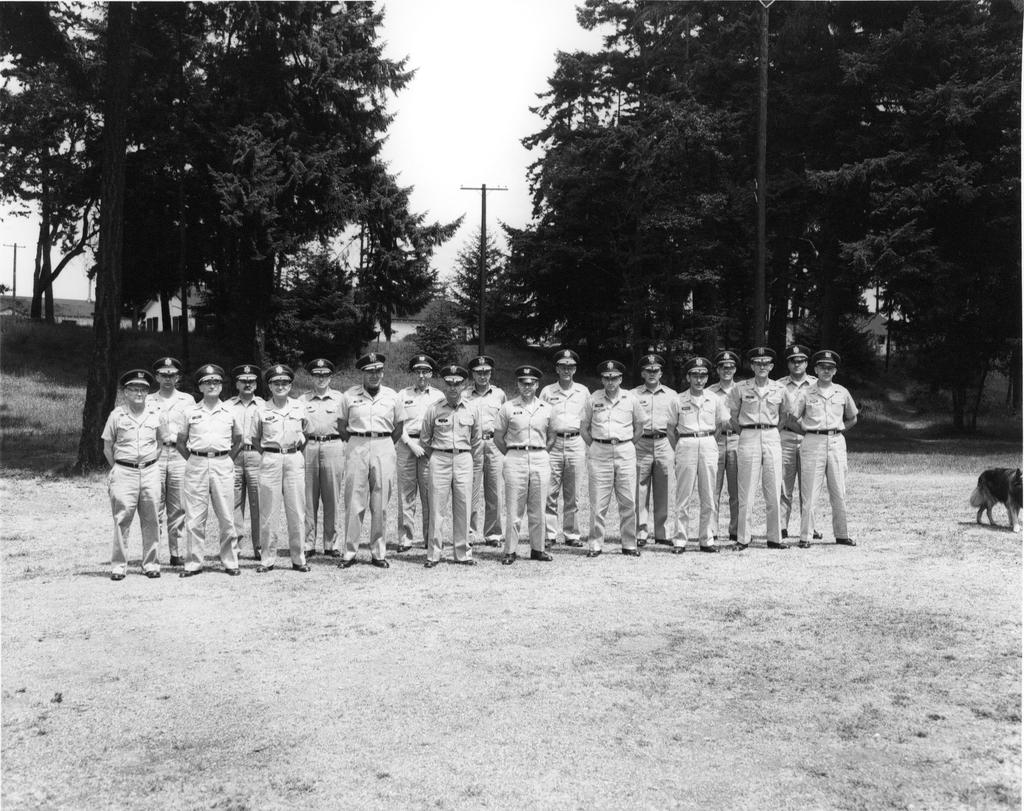What type of people can be seen in the image? There are police officers in the image. What are the police officers doing in the image? The police officers are standing. What can be seen in the right corner of the image? There is a dog in the right corner of the image. What is visible in the background of the image? There are trees and poles in the background of the image. What type of work is the cannon doing in the image? There is no cannon present in the image, so it cannot be doing any work. What type of joke is being told by the police officers in the image? There is no indication in the image that the police officers are telling a joke, so it cannot be determined from the picture. 